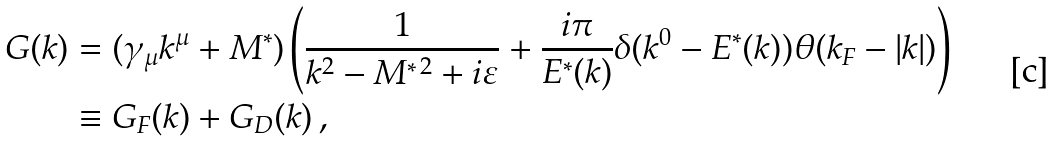<formula> <loc_0><loc_0><loc_500><loc_500>G ( k ) & = ( \gamma _ { \mu } k ^ { \mu } + M ^ { \ast } ) \left ( \frac { 1 } { k ^ { 2 } - M ^ { \ast \, 2 } + i \varepsilon } + \frac { i \pi } { E ^ { \ast } ( k ) } \delta ( k ^ { 0 } - E ^ { \ast } ( k ) ) \theta ( k _ { F } - | k | ) \right ) \\ & \equiv G _ { F } ( k ) + G _ { D } ( k ) \, ,</formula> 